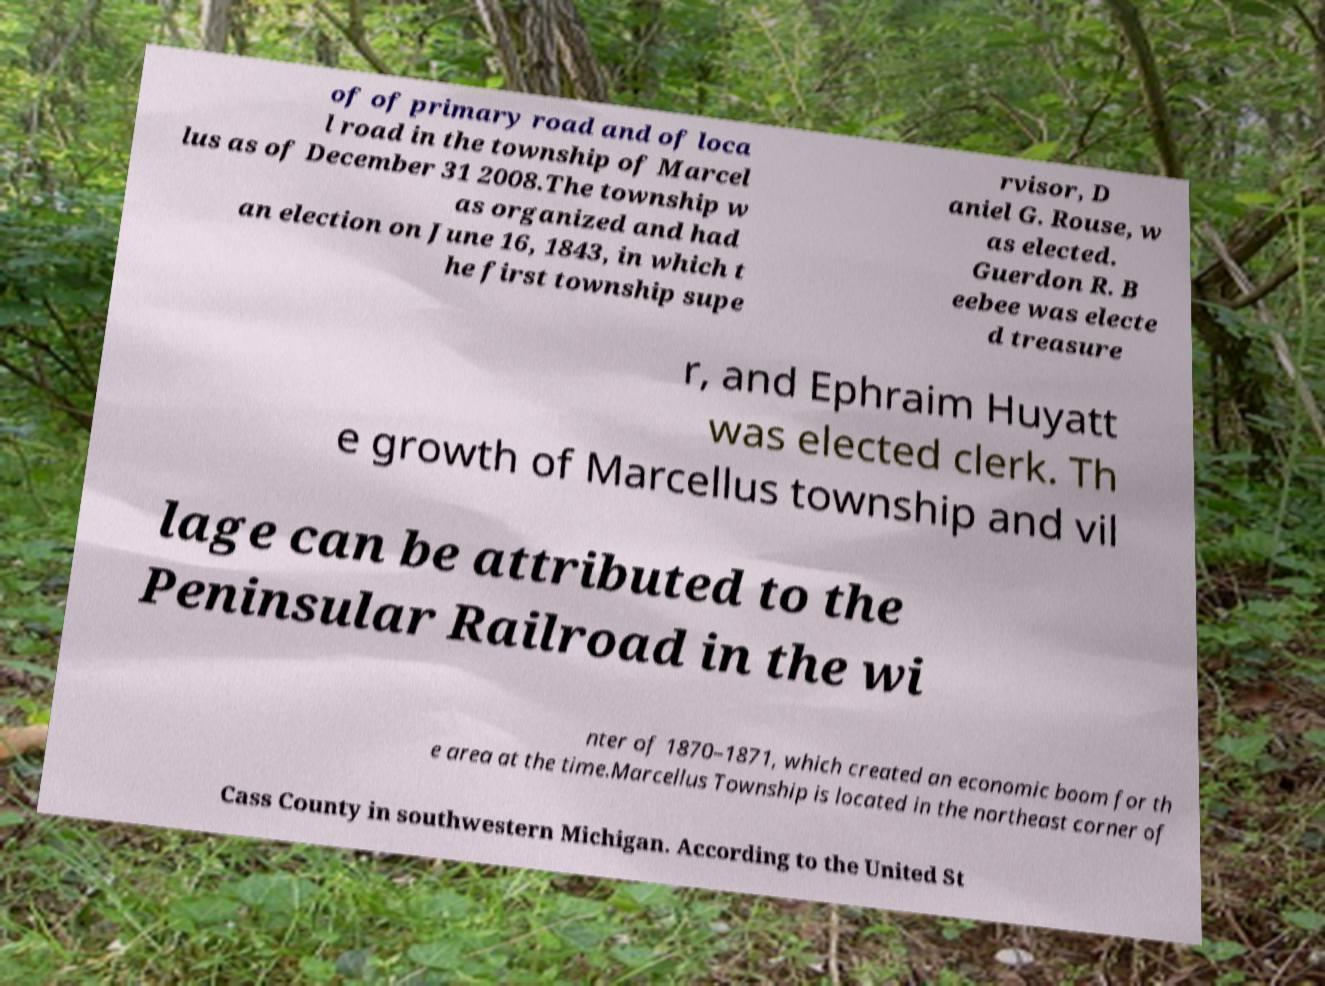Could you extract and type out the text from this image? of of primary road and of loca l road in the township of Marcel lus as of December 31 2008.The township w as organized and had an election on June 16, 1843, in which t he first township supe rvisor, D aniel G. Rouse, w as elected. Guerdon R. B eebee was electe d treasure r, and Ephraim Huyatt was elected clerk. Th e growth of Marcellus township and vil lage can be attributed to the Peninsular Railroad in the wi nter of 1870–1871, which created an economic boom for th e area at the time.Marcellus Township is located in the northeast corner of Cass County in southwestern Michigan. According to the United St 